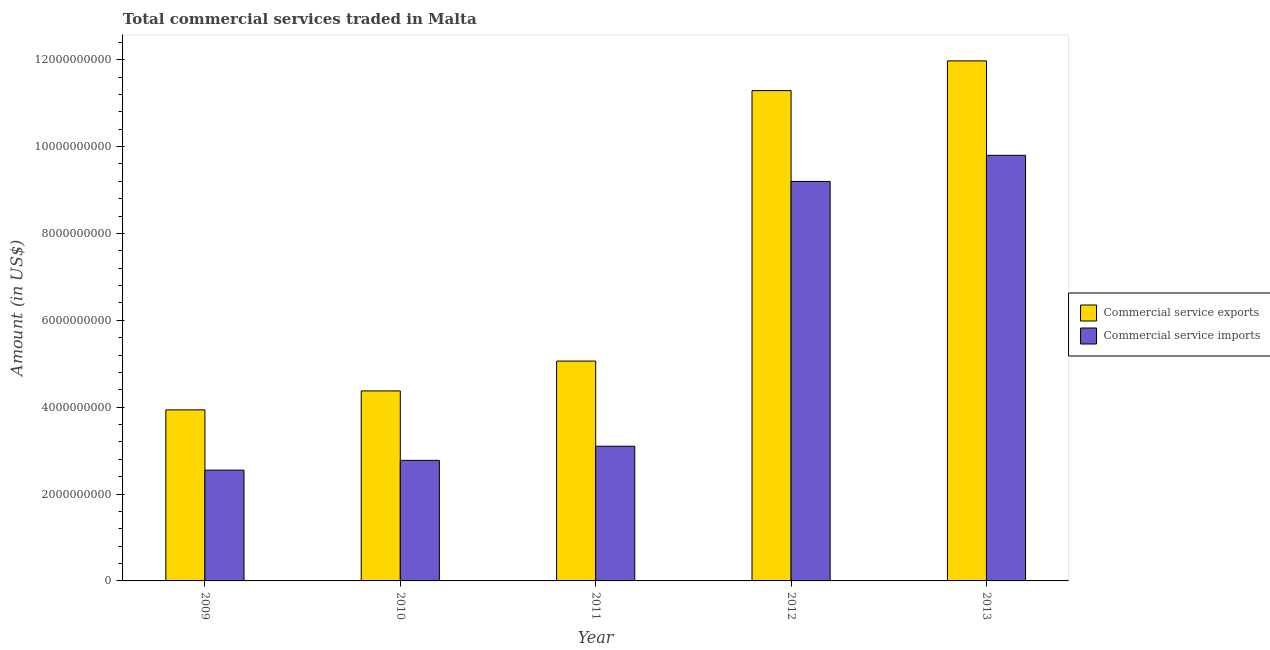Are the number of bars per tick equal to the number of legend labels?
Give a very brief answer. Yes. What is the amount of commercial service exports in 2009?
Your response must be concise. 3.94e+09. Across all years, what is the maximum amount of commercial service exports?
Provide a succinct answer. 1.20e+1. Across all years, what is the minimum amount of commercial service exports?
Keep it short and to the point. 3.94e+09. What is the total amount of commercial service imports in the graph?
Give a very brief answer. 2.74e+1. What is the difference between the amount of commercial service exports in 2011 and that in 2013?
Provide a short and direct response. -6.91e+09. What is the difference between the amount of commercial service imports in 2011 and the amount of commercial service exports in 2009?
Provide a succinct answer. 5.51e+08. What is the average amount of commercial service exports per year?
Your answer should be compact. 7.33e+09. In the year 2012, what is the difference between the amount of commercial service imports and amount of commercial service exports?
Your answer should be very brief. 0. In how many years, is the amount of commercial service imports greater than 10800000000 US$?
Make the answer very short. 0. What is the ratio of the amount of commercial service exports in 2011 to that in 2012?
Ensure brevity in your answer.  0.45. What is the difference between the highest and the second highest amount of commercial service imports?
Make the answer very short. 6.02e+08. What is the difference between the highest and the lowest amount of commercial service exports?
Provide a succinct answer. 8.03e+09. In how many years, is the amount of commercial service exports greater than the average amount of commercial service exports taken over all years?
Provide a short and direct response. 2. Is the sum of the amount of commercial service imports in 2011 and 2012 greater than the maximum amount of commercial service exports across all years?
Make the answer very short. Yes. What does the 2nd bar from the left in 2013 represents?
Keep it short and to the point. Commercial service imports. What does the 2nd bar from the right in 2009 represents?
Keep it short and to the point. Commercial service exports. How many bars are there?
Your response must be concise. 10. How many years are there in the graph?
Offer a very short reply. 5. Are the values on the major ticks of Y-axis written in scientific E-notation?
Your answer should be compact. No. Where does the legend appear in the graph?
Your response must be concise. Center right. How are the legend labels stacked?
Keep it short and to the point. Vertical. What is the title of the graph?
Provide a succinct answer. Total commercial services traded in Malta. Does "Urban" appear as one of the legend labels in the graph?
Your response must be concise. No. What is the Amount (in US$) of Commercial service exports in 2009?
Make the answer very short. 3.94e+09. What is the Amount (in US$) of Commercial service imports in 2009?
Your answer should be compact. 2.55e+09. What is the Amount (in US$) in Commercial service exports in 2010?
Offer a very short reply. 4.37e+09. What is the Amount (in US$) of Commercial service imports in 2010?
Offer a very short reply. 2.78e+09. What is the Amount (in US$) of Commercial service exports in 2011?
Your answer should be compact. 5.06e+09. What is the Amount (in US$) in Commercial service imports in 2011?
Give a very brief answer. 3.10e+09. What is the Amount (in US$) in Commercial service exports in 2012?
Your answer should be very brief. 1.13e+1. What is the Amount (in US$) of Commercial service imports in 2012?
Make the answer very short. 9.20e+09. What is the Amount (in US$) of Commercial service exports in 2013?
Ensure brevity in your answer.  1.20e+1. What is the Amount (in US$) in Commercial service imports in 2013?
Your answer should be compact. 9.80e+09. Across all years, what is the maximum Amount (in US$) in Commercial service exports?
Make the answer very short. 1.20e+1. Across all years, what is the maximum Amount (in US$) of Commercial service imports?
Your response must be concise. 9.80e+09. Across all years, what is the minimum Amount (in US$) of Commercial service exports?
Provide a succinct answer. 3.94e+09. Across all years, what is the minimum Amount (in US$) in Commercial service imports?
Your response must be concise. 2.55e+09. What is the total Amount (in US$) of Commercial service exports in the graph?
Your answer should be compact. 3.66e+1. What is the total Amount (in US$) in Commercial service imports in the graph?
Your answer should be compact. 2.74e+1. What is the difference between the Amount (in US$) of Commercial service exports in 2009 and that in 2010?
Give a very brief answer. -4.36e+08. What is the difference between the Amount (in US$) of Commercial service imports in 2009 and that in 2010?
Keep it short and to the point. -2.25e+08. What is the difference between the Amount (in US$) in Commercial service exports in 2009 and that in 2011?
Your answer should be very brief. -1.12e+09. What is the difference between the Amount (in US$) of Commercial service imports in 2009 and that in 2011?
Provide a succinct answer. -5.51e+08. What is the difference between the Amount (in US$) of Commercial service exports in 2009 and that in 2012?
Your answer should be very brief. -7.35e+09. What is the difference between the Amount (in US$) in Commercial service imports in 2009 and that in 2012?
Provide a short and direct response. -6.65e+09. What is the difference between the Amount (in US$) of Commercial service exports in 2009 and that in 2013?
Your answer should be very brief. -8.03e+09. What is the difference between the Amount (in US$) of Commercial service imports in 2009 and that in 2013?
Offer a very short reply. -7.25e+09. What is the difference between the Amount (in US$) in Commercial service exports in 2010 and that in 2011?
Keep it short and to the point. -6.87e+08. What is the difference between the Amount (in US$) in Commercial service imports in 2010 and that in 2011?
Keep it short and to the point. -3.25e+08. What is the difference between the Amount (in US$) in Commercial service exports in 2010 and that in 2012?
Your answer should be compact. -6.91e+09. What is the difference between the Amount (in US$) of Commercial service imports in 2010 and that in 2012?
Your response must be concise. -6.42e+09. What is the difference between the Amount (in US$) of Commercial service exports in 2010 and that in 2013?
Your response must be concise. -7.60e+09. What is the difference between the Amount (in US$) in Commercial service imports in 2010 and that in 2013?
Provide a short and direct response. -7.02e+09. What is the difference between the Amount (in US$) in Commercial service exports in 2011 and that in 2012?
Offer a terse response. -6.23e+09. What is the difference between the Amount (in US$) in Commercial service imports in 2011 and that in 2012?
Your answer should be compact. -6.10e+09. What is the difference between the Amount (in US$) in Commercial service exports in 2011 and that in 2013?
Provide a succinct answer. -6.91e+09. What is the difference between the Amount (in US$) of Commercial service imports in 2011 and that in 2013?
Offer a very short reply. -6.70e+09. What is the difference between the Amount (in US$) in Commercial service exports in 2012 and that in 2013?
Your response must be concise. -6.85e+08. What is the difference between the Amount (in US$) of Commercial service imports in 2012 and that in 2013?
Your response must be concise. -6.02e+08. What is the difference between the Amount (in US$) in Commercial service exports in 2009 and the Amount (in US$) in Commercial service imports in 2010?
Give a very brief answer. 1.16e+09. What is the difference between the Amount (in US$) in Commercial service exports in 2009 and the Amount (in US$) in Commercial service imports in 2011?
Make the answer very short. 8.37e+08. What is the difference between the Amount (in US$) of Commercial service exports in 2009 and the Amount (in US$) of Commercial service imports in 2012?
Provide a short and direct response. -5.26e+09. What is the difference between the Amount (in US$) in Commercial service exports in 2009 and the Amount (in US$) in Commercial service imports in 2013?
Give a very brief answer. -5.86e+09. What is the difference between the Amount (in US$) of Commercial service exports in 2010 and the Amount (in US$) of Commercial service imports in 2011?
Provide a succinct answer. 1.27e+09. What is the difference between the Amount (in US$) in Commercial service exports in 2010 and the Amount (in US$) in Commercial service imports in 2012?
Provide a succinct answer. -4.82e+09. What is the difference between the Amount (in US$) of Commercial service exports in 2010 and the Amount (in US$) of Commercial service imports in 2013?
Provide a succinct answer. -5.42e+09. What is the difference between the Amount (in US$) in Commercial service exports in 2011 and the Amount (in US$) in Commercial service imports in 2012?
Provide a short and direct response. -4.13e+09. What is the difference between the Amount (in US$) of Commercial service exports in 2011 and the Amount (in US$) of Commercial service imports in 2013?
Make the answer very short. -4.74e+09. What is the difference between the Amount (in US$) of Commercial service exports in 2012 and the Amount (in US$) of Commercial service imports in 2013?
Your answer should be very brief. 1.49e+09. What is the average Amount (in US$) in Commercial service exports per year?
Give a very brief answer. 7.33e+09. What is the average Amount (in US$) of Commercial service imports per year?
Give a very brief answer. 5.48e+09. In the year 2009, what is the difference between the Amount (in US$) of Commercial service exports and Amount (in US$) of Commercial service imports?
Your answer should be very brief. 1.39e+09. In the year 2010, what is the difference between the Amount (in US$) in Commercial service exports and Amount (in US$) in Commercial service imports?
Ensure brevity in your answer.  1.60e+09. In the year 2011, what is the difference between the Amount (in US$) in Commercial service exports and Amount (in US$) in Commercial service imports?
Keep it short and to the point. 1.96e+09. In the year 2012, what is the difference between the Amount (in US$) of Commercial service exports and Amount (in US$) of Commercial service imports?
Make the answer very short. 2.09e+09. In the year 2013, what is the difference between the Amount (in US$) in Commercial service exports and Amount (in US$) in Commercial service imports?
Provide a succinct answer. 2.17e+09. What is the ratio of the Amount (in US$) of Commercial service exports in 2009 to that in 2010?
Make the answer very short. 0.9. What is the ratio of the Amount (in US$) in Commercial service imports in 2009 to that in 2010?
Offer a terse response. 0.92. What is the ratio of the Amount (in US$) in Commercial service exports in 2009 to that in 2011?
Your response must be concise. 0.78. What is the ratio of the Amount (in US$) of Commercial service imports in 2009 to that in 2011?
Provide a succinct answer. 0.82. What is the ratio of the Amount (in US$) in Commercial service exports in 2009 to that in 2012?
Offer a terse response. 0.35. What is the ratio of the Amount (in US$) in Commercial service imports in 2009 to that in 2012?
Provide a succinct answer. 0.28. What is the ratio of the Amount (in US$) of Commercial service exports in 2009 to that in 2013?
Your answer should be very brief. 0.33. What is the ratio of the Amount (in US$) of Commercial service imports in 2009 to that in 2013?
Give a very brief answer. 0.26. What is the ratio of the Amount (in US$) in Commercial service exports in 2010 to that in 2011?
Ensure brevity in your answer.  0.86. What is the ratio of the Amount (in US$) in Commercial service imports in 2010 to that in 2011?
Give a very brief answer. 0.9. What is the ratio of the Amount (in US$) of Commercial service exports in 2010 to that in 2012?
Offer a terse response. 0.39. What is the ratio of the Amount (in US$) in Commercial service imports in 2010 to that in 2012?
Make the answer very short. 0.3. What is the ratio of the Amount (in US$) in Commercial service exports in 2010 to that in 2013?
Offer a very short reply. 0.37. What is the ratio of the Amount (in US$) of Commercial service imports in 2010 to that in 2013?
Provide a short and direct response. 0.28. What is the ratio of the Amount (in US$) of Commercial service exports in 2011 to that in 2012?
Provide a succinct answer. 0.45. What is the ratio of the Amount (in US$) in Commercial service imports in 2011 to that in 2012?
Offer a terse response. 0.34. What is the ratio of the Amount (in US$) of Commercial service exports in 2011 to that in 2013?
Your response must be concise. 0.42. What is the ratio of the Amount (in US$) in Commercial service imports in 2011 to that in 2013?
Your response must be concise. 0.32. What is the ratio of the Amount (in US$) of Commercial service exports in 2012 to that in 2013?
Your answer should be very brief. 0.94. What is the ratio of the Amount (in US$) in Commercial service imports in 2012 to that in 2013?
Ensure brevity in your answer.  0.94. What is the difference between the highest and the second highest Amount (in US$) in Commercial service exports?
Your answer should be compact. 6.85e+08. What is the difference between the highest and the second highest Amount (in US$) in Commercial service imports?
Make the answer very short. 6.02e+08. What is the difference between the highest and the lowest Amount (in US$) in Commercial service exports?
Keep it short and to the point. 8.03e+09. What is the difference between the highest and the lowest Amount (in US$) of Commercial service imports?
Offer a very short reply. 7.25e+09. 